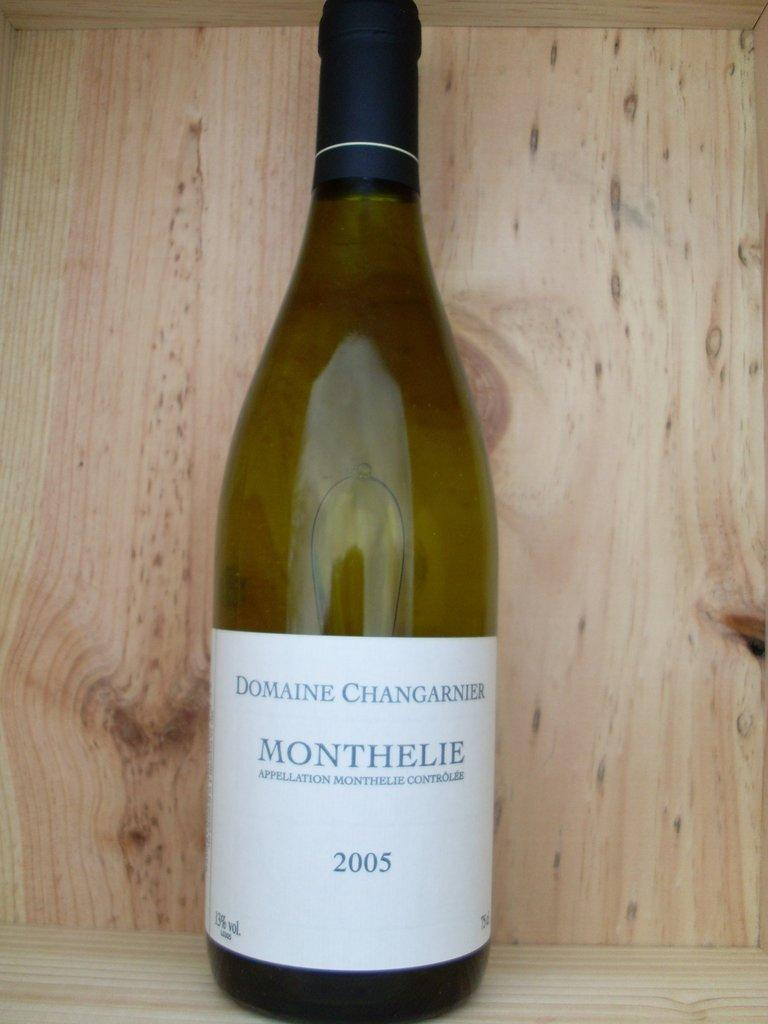Provide a one-sentence caption for the provided image. A bottled of wine called Monthelie that was bottled in 2005. 